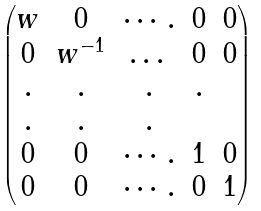<formula> <loc_0><loc_0><loc_500><loc_500>\begin{pmatrix} w & 0 & \cdots . & 0 & 0 \\ 0 & w ^ { - 1 } & \dots & 0 & 0 \\ . & . & . & . & \\ . & . & . & \\ 0 & 0 & \cdots . & 1 & 0 \\ 0 & 0 & \cdots . & 0 & 1 \end{pmatrix}</formula> 